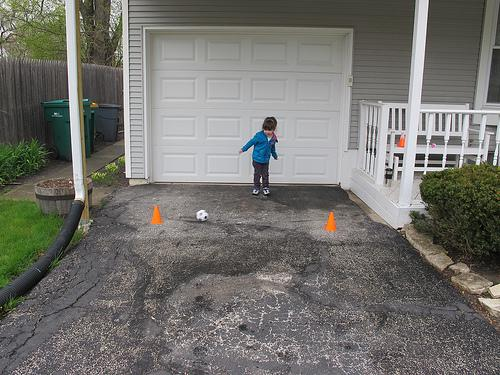Can you spot the difference between the two smallest objects on the bench and on the driveway? The small orange cone on the bench is slightly smaller than the one on the driveway. Select an appropriate caption to describe the young girl's activity. A young girl playing soccer with a small black and white ball. Choose three objects in the image connected to sports or outdoor activities and describe their colors. A small orange cone on the driveway, a small soccer ball in black and white, and a blue jacket on the child. Mention a color-related attribute of the garage door and the house. The garage door is white, and the house is gray. Which object(s) can be found on the porch and describe their appearance? A white bench and a wooden railing, both with a pretty design, can be found on the porch. If you were to advertise an object in the image, which would it be and why? The small soccer ball, because it encourages outdoor sports and physical activity for kids. Find and describe the condition of the driveway in terms of its surface and color. The driveway is black with cracked asphalt, spanning a large area of the image. Identify the object located on the driveway next to the young girl and describe its characteristics. A small soccer ball, black and white in color, is on the driveway next to the girl. Provide a description of the colors of the two green recycle bins and the gray trash bin. Two green recycle bins and one gray trash bin are placed beside the garage. What is the prominent object in the front center of the image? A small boy in a blue jacket is standing in front of the garage. 